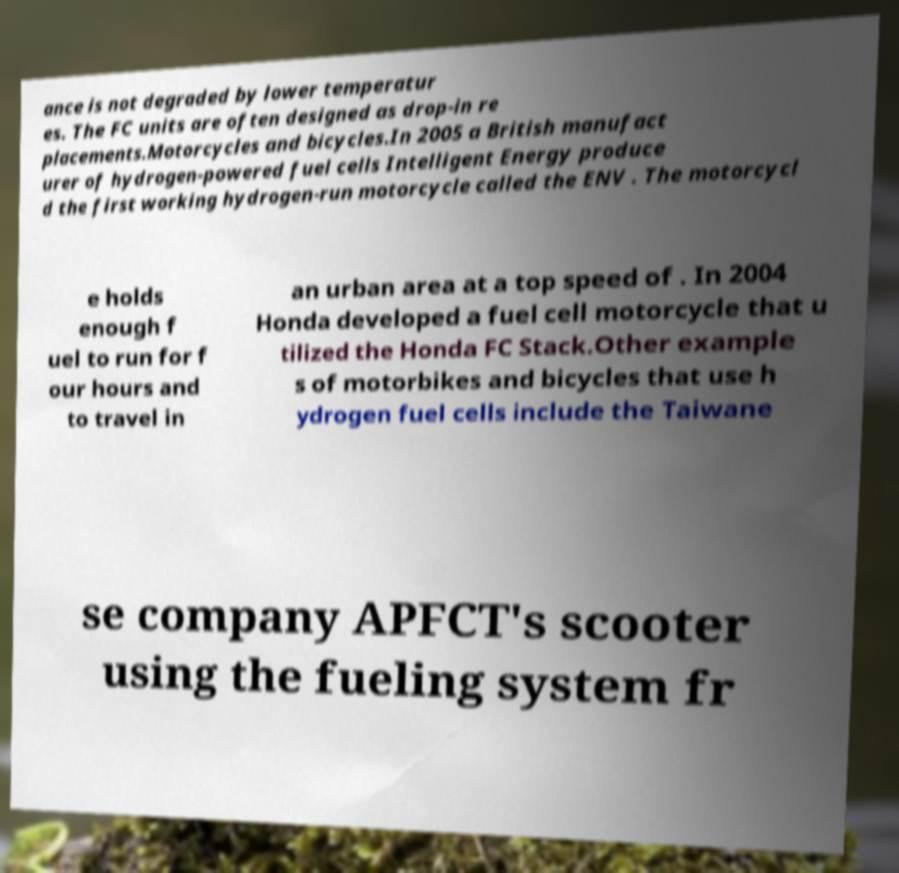Can you accurately transcribe the text from the provided image for me? ance is not degraded by lower temperatur es. The FC units are often designed as drop-in re placements.Motorcycles and bicycles.In 2005 a British manufact urer of hydrogen-powered fuel cells Intelligent Energy produce d the first working hydrogen-run motorcycle called the ENV . The motorcycl e holds enough f uel to run for f our hours and to travel in an urban area at a top speed of . In 2004 Honda developed a fuel cell motorcycle that u tilized the Honda FC Stack.Other example s of motorbikes and bicycles that use h ydrogen fuel cells include the Taiwane se company APFCT's scooter using the fueling system fr 